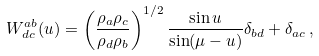Convert formula to latex. <formula><loc_0><loc_0><loc_500><loc_500>W ^ { a b } _ { d c } ( u ) = \left ( \frac { \rho _ { a } \rho _ { c } } { \rho _ { d } \rho _ { b } } \right ) ^ { 1 / 2 } \frac { \sin u } { \sin ( \mu - u ) } \delta _ { b d } + \delta _ { a c } \, ,</formula> 